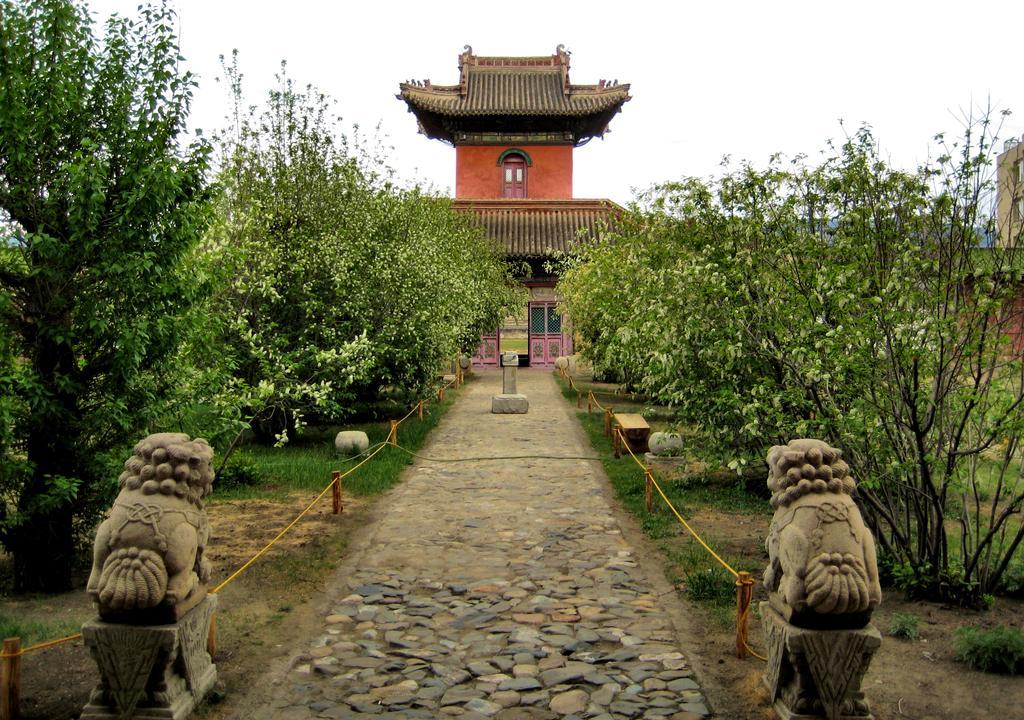Can you describe this image briefly? In the image there is a building and in front of that there are a lot of trees and there is a path in between those trees and there are two sculptures on the left side and right side of the path. 